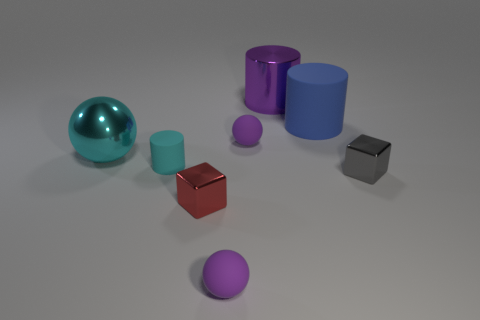Add 1 tiny cyan things. How many objects exist? 9 Subtract all cylinders. How many objects are left? 5 Add 7 gray objects. How many gray objects are left? 8 Add 5 cylinders. How many cylinders exist? 8 Subtract 1 gray blocks. How many objects are left? 7 Subtract all metal balls. Subtract all large purple metal cylinders. How many objects are left? 6 